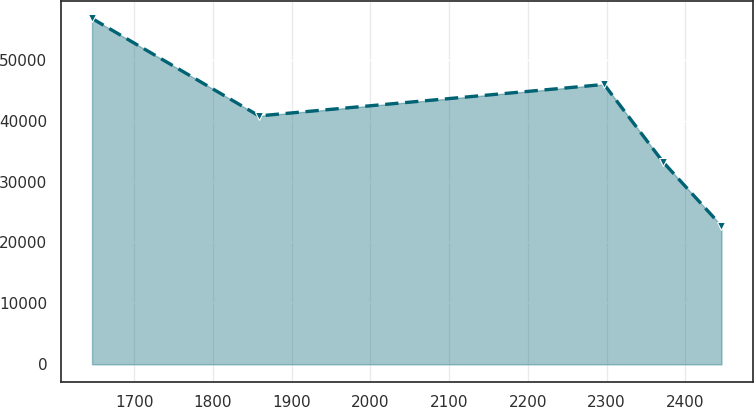Convert chart to OTSL. <chart><loc_0><loc_0><loc_500><loc_500><line_chart><ecel><fcel>Unnamed: 1<nl><fcel>1646.37<fcel>56758.3<nl><fcel>1858.52<fcel>40769.9<nl><fcel>2297<fcel>45932<nl><fcel>2371.5<fcel>33251.5<nl><fcel>2446<fcel>22724.6<nl></chart> 